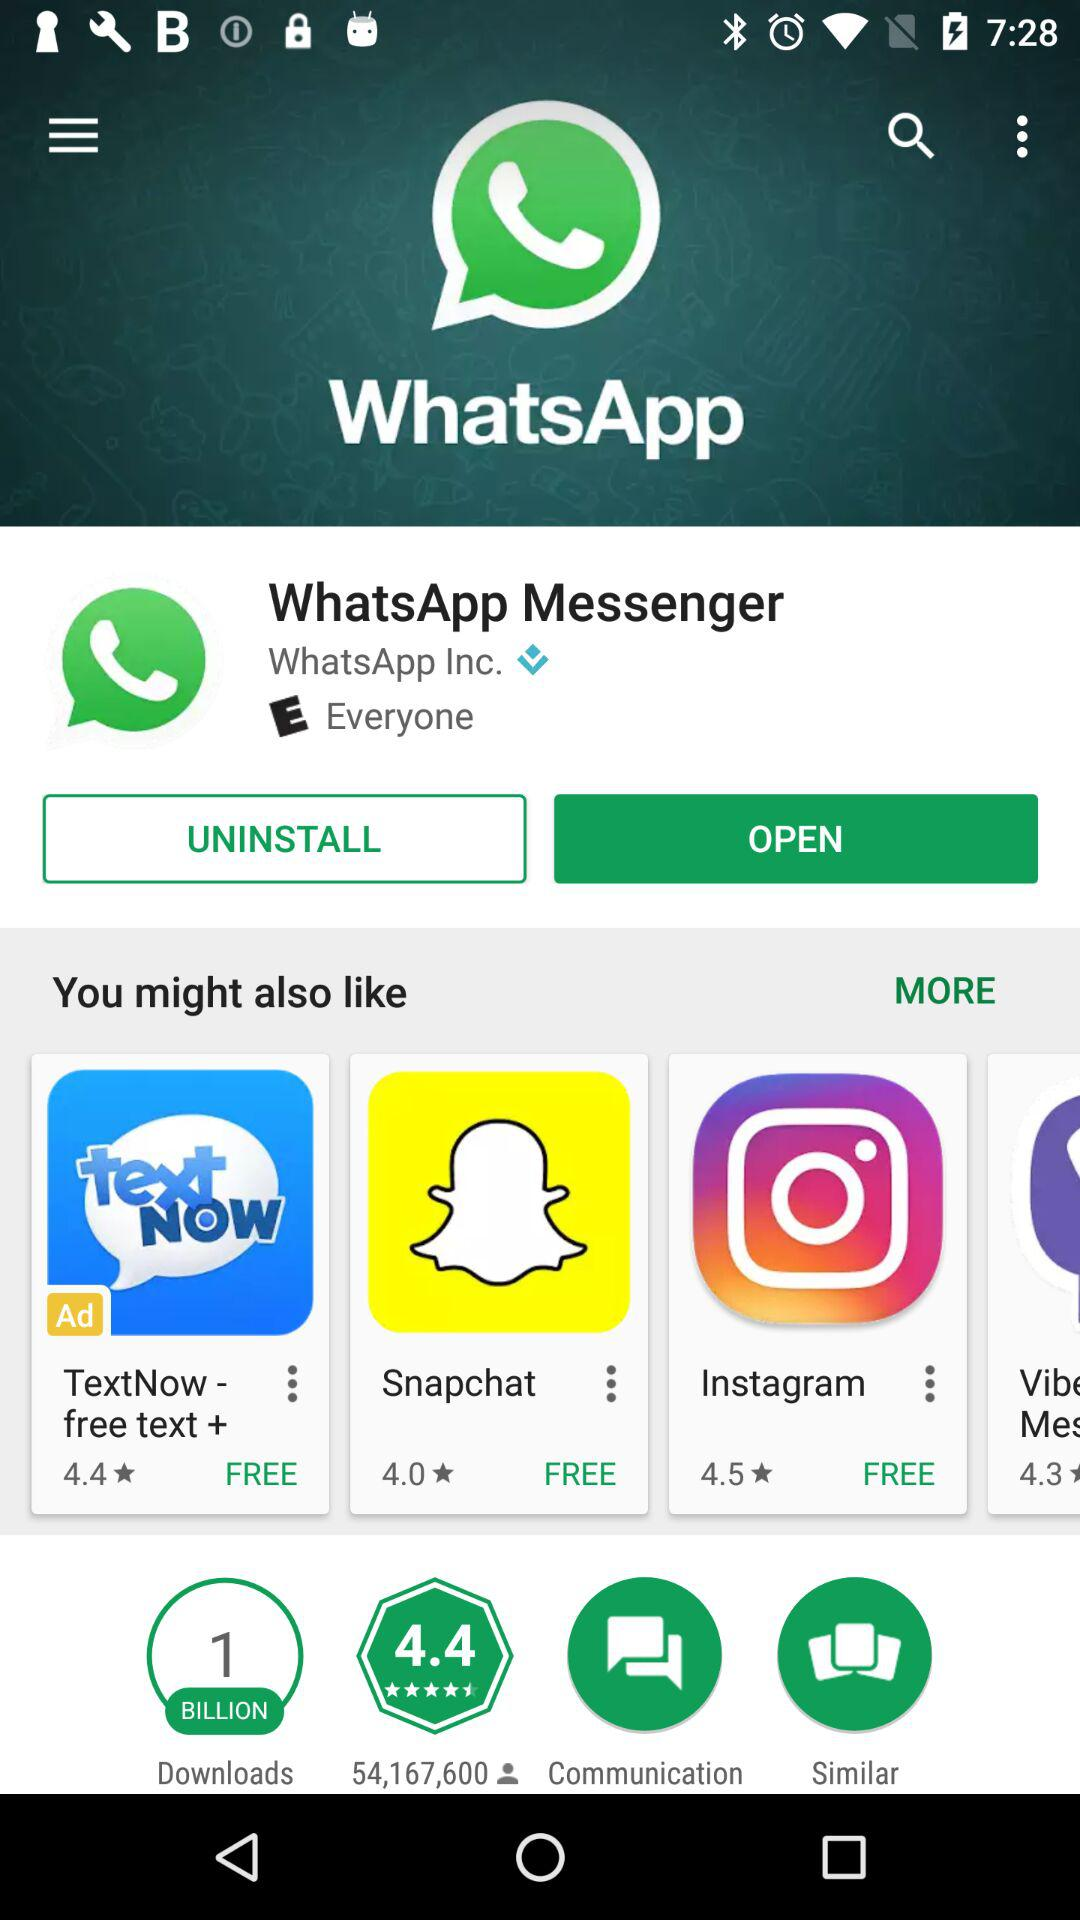What is the number of downloads for WhatsApp Messenger? The number of downloads for Whatsapp Messenger is 1 billion. 